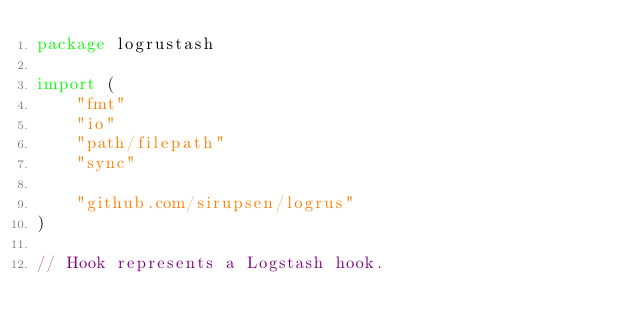<code> <loc_0><loc_0><loc_500><loc_500><_Go_>package logrustash

import (
	"fmt"
	"io"
	"path/filepath"
	"sync"

	"github.com/sirupsen/logrus"
)

// Hook represents a Logstash hook.</code> 